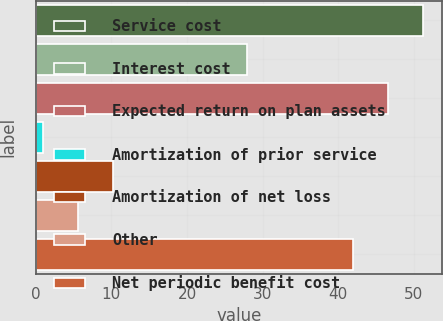<chart> <loc_0><loc_0><loc_500><loc_500><bar_chart><fcel>Service cost<fcel>Interest cost<fcel>Expected return on plan assets<fcel>Amortization of prior service<fcel>Amortization of net loss<fcel>Other<fcel>Net periodic benefit cost<nl><fcel>51.2<fcel>28<fcel>46.6<fcel>1<fcel>10.2<fcel>5.6<fcel>42<nl></chart> 